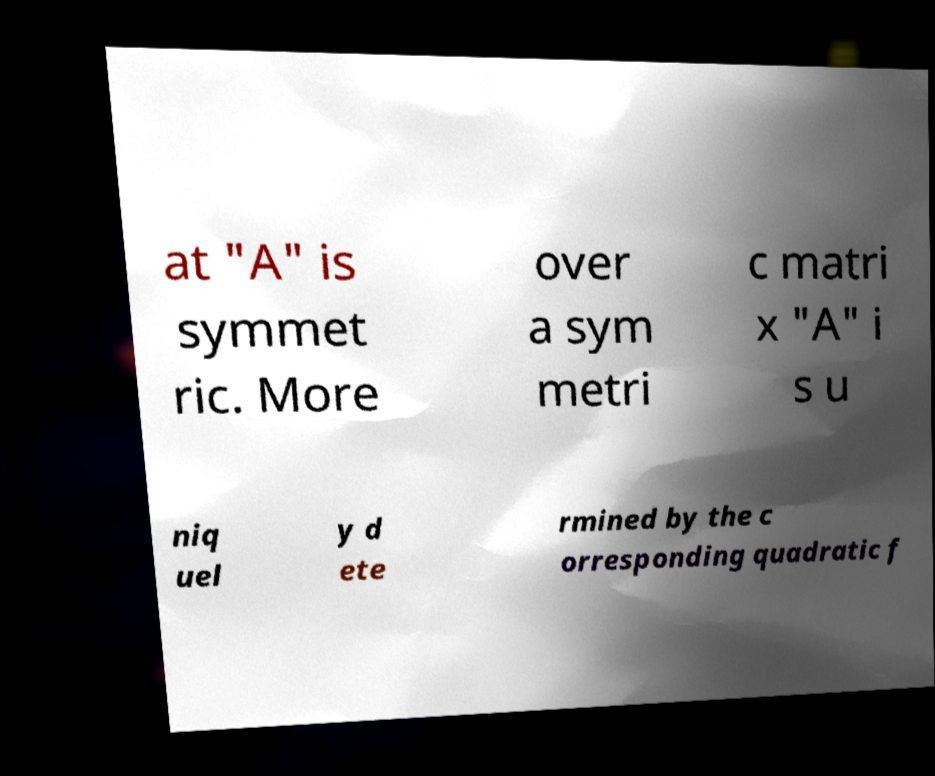Can you read and provide the text displayed in the image?This photo seems to have some interesting text. Can you extract and type it out for me? at "A" is symmet ric. More over a sym metri c matri x "A" i s u niq uel y d ete rmined by the c orresponding quadratic f 